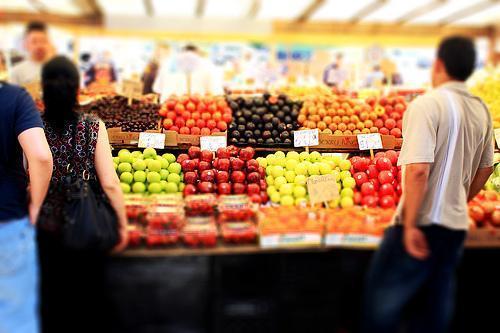How many people are in front of the fruit stand?
Give a very brief answer. 3. How many apples are in the picture?
Give a very brief answer. 2. How many people are there?
Give a very brief answer. 5. 